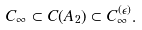Convert formula to latex. <formula><loc_0><loc_0><loc_500><loc_500>C _ { \infty } \subset C ( A _ { 2 } ) \subset C _ { \infty } ^ { ( \epsilon ) } .</formula> 